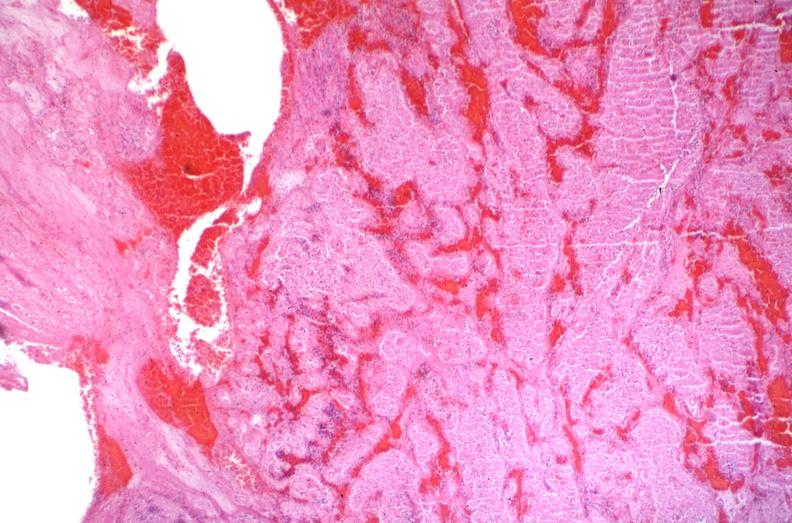does this image show sickle cell disease, thrombus?
Answer the question using a single word or phrase. Yes 